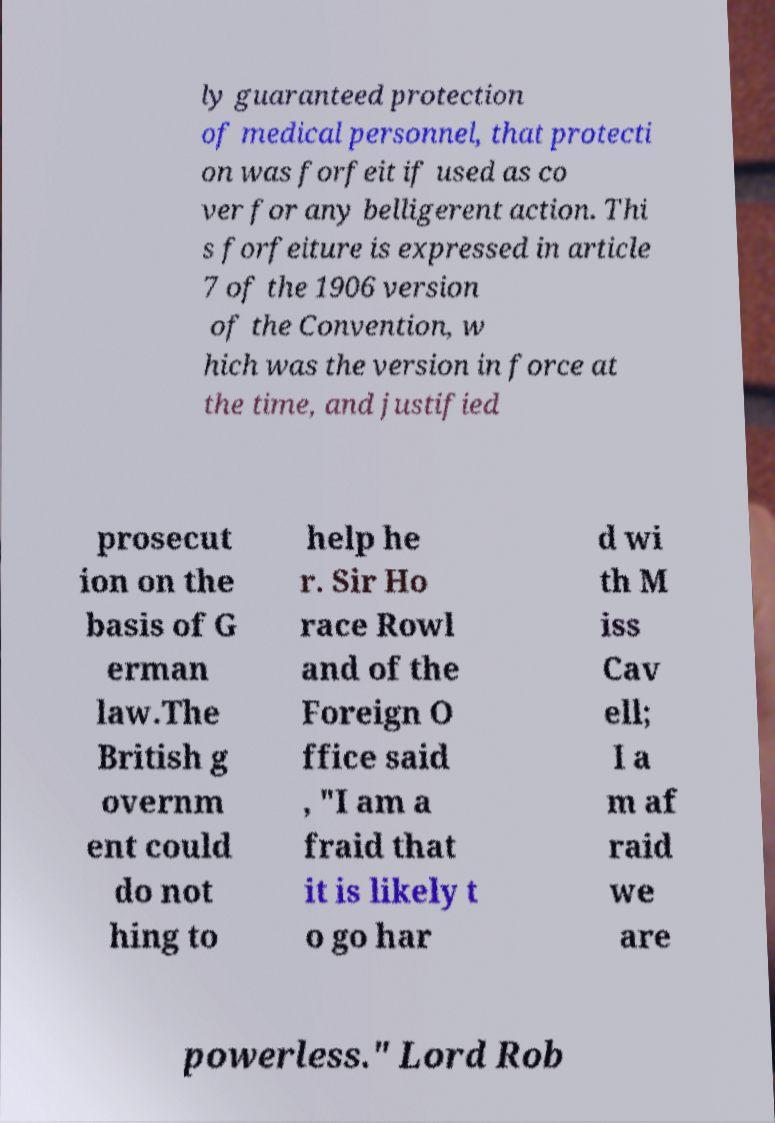Could you assist in decoding the text presented in this image and type it out clearly? ly guaranteed protection of medical personnel, that protecti on was forfeit if used as co ver for any belligerent action. Thi s forfeiture is expressed in article 7 of the 1906 version of the Convention, w hich was the version in force at the time, and justified prosecut ion on the basis of G erman law.The British g overnm ent could do not hing to help he r. Sir Ho race Rowl and of the Foreign O ffice said , "I am a fraid that it is likely t o go har d wi th M iss Cav ell; I a m af raid we are powerless." Lord Rob 